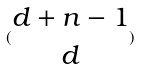<formula> <loc_0><loc_0><loc_500><loc_500>( \begin{matrix} d + n - 1 \\ d \end{matrix} )</formula> 